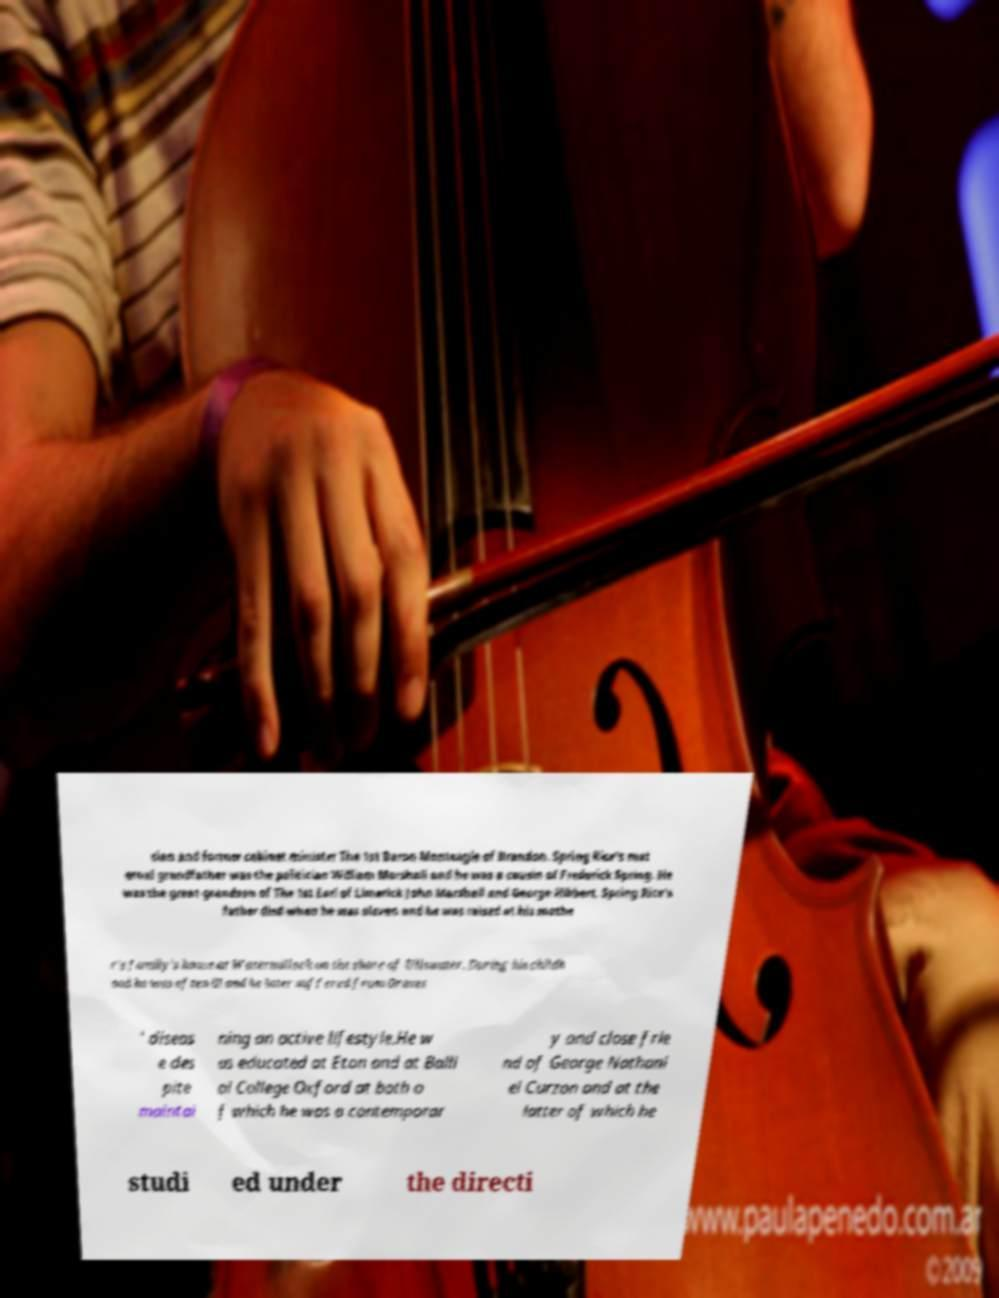Can you accurately transcribe the text from the provided image for me? cian and former cabinet minister The 1st Baron Monteagle of Brandon. Spring Rice's mat ernal grandfather was the politician William Marshall and he was a cousin of Frederick Spring. He was the great-grandson of The 1st Earl of Limerick John Marshall and George Hibbert. Spring Rice's father died when he was eleven and he was raised at his mothe r's family's house at Watermillock on the shore of Ullswater. During his childh ood he was often ill and he later suffered from Graves ' diseas e des pite maintai ning an active lifestyle.He w as educated at Eton and at Balli ol College Oxford at both o f which he was a contemporar y and close frie nd of George Nathani el Curzon and at the latter of which he studi ed under the directi 